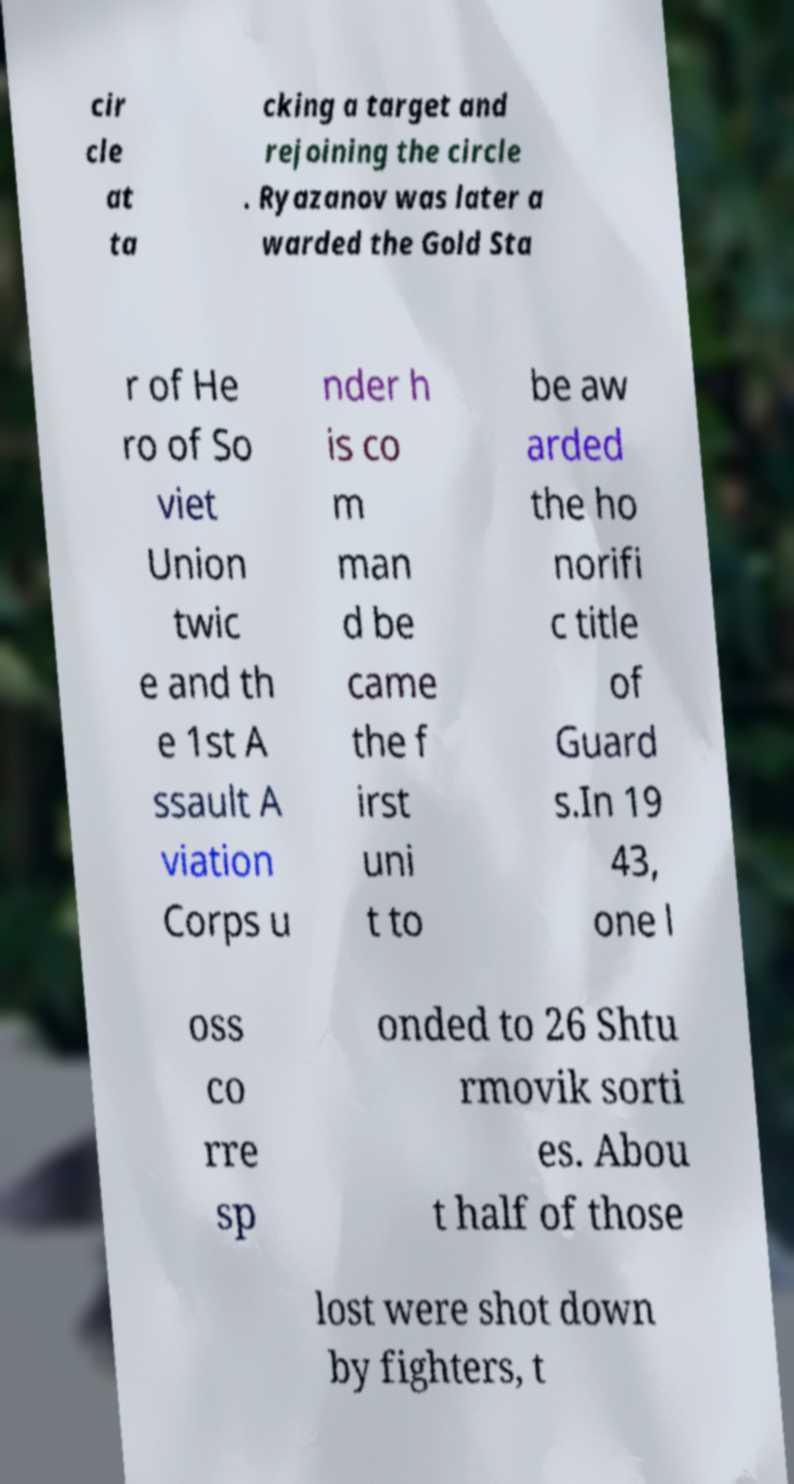Could you extract and type out the text from this image? cir cle at ta cking a target and rejoining the circle . Ryazanov was later a warded the Gold Sta r of He ro of So viet Union twic e and th e 1st A ssault A viation Corps u nder h is co m man d be came the f irst uni t to be aw arded the ho norifi c title of Guard s.In 19 43, one l oss co rre sp onded to 26 Shtu rmovik sorti es. Abou t half of those lost were shot down by fighters, t 